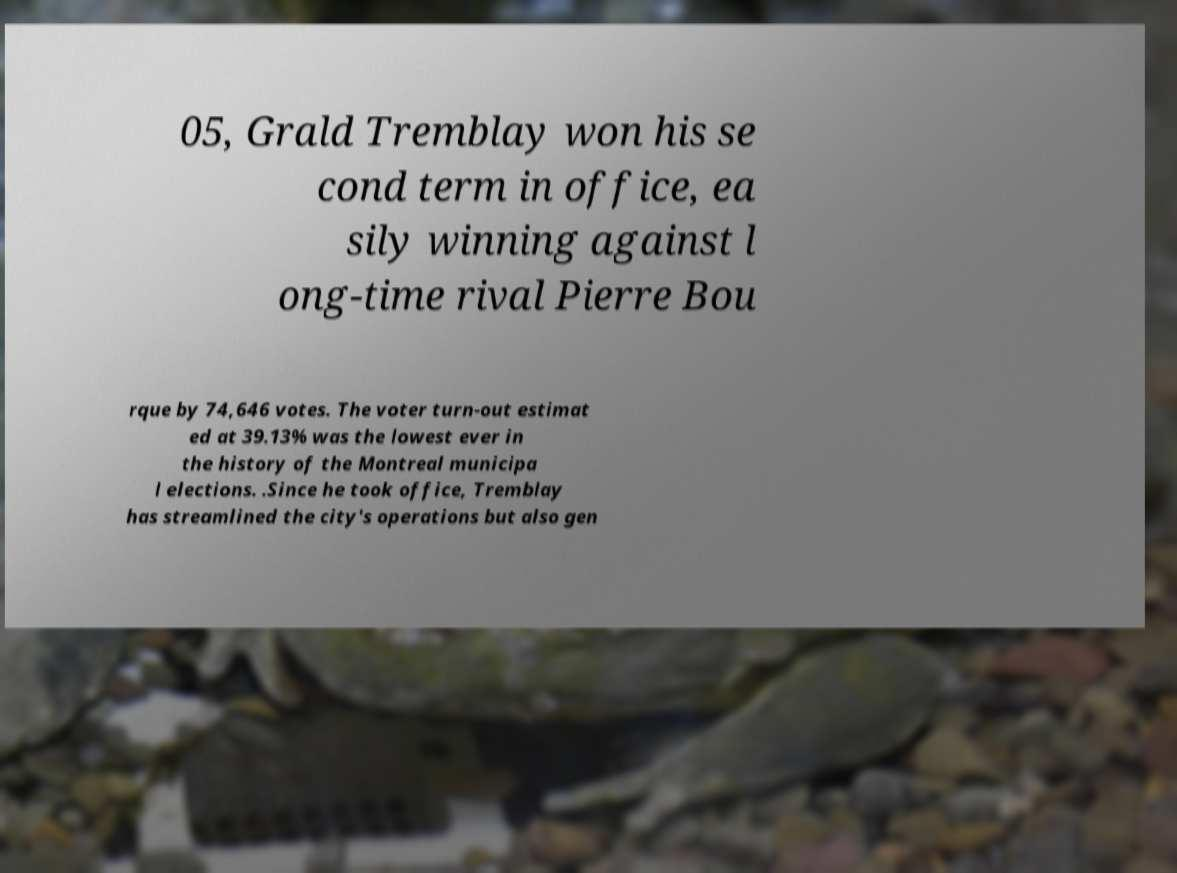What messages or text are displayed in this image? I need them in a readable, typed format. 05, Grald Tremblay won his se cond term in office, ea sily winning against l ong-time rival Pierre Bou rque by 74,646 votes. The voter turn-out estimat ed at 39.13% was the lowest ever in the history of the Montreal municipa l elections. .Since he took office, Tremblay has streamlined the city's operations but also gen 